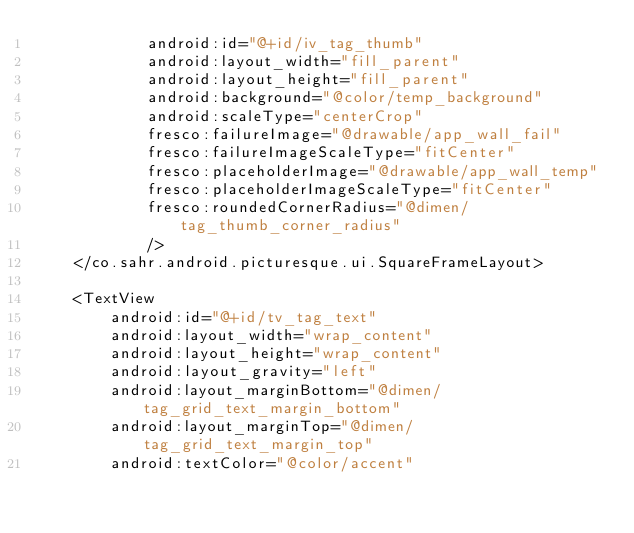Convert code to text. <code><loc_0><loc_0><loc_500><loc_500><_XML_>            android:id="@+id/iv_tag_thumb"
            android:layout_width="fill_parent"
            android:layout_height="fill_parent"
            android:background="@color/temp_background"
            android:scaleType="centerCrop"
            fresco:failureImage="@drawable/app_wall_fail"
            fresco:failureImageScaleType="fitCenter"
            fresco:placeholderImage="@drawable/app_wall_temp"
            fresco:placeholderImageScaleType="fitCenter"
            fresco:roundedCornerRadius="@dimen/tag_thumb_corner_radius"
            />
    </co.sahr.android.picturesque.ui.SquareFrameLayout>

    <TextView
        android:id="@+id/tv_tag_text"
        android:layout_width="wrap_content"
        android:layout_height="wrap_content"
        android:layout_gravity="left"
        android:layout_marginBottom="@dimen/tag_grid_text_margin_bottom"
        android:layout_marginTop="@dimen/tag_grid_text_margin_top"
        android:textColor="@color/accent"</code> 